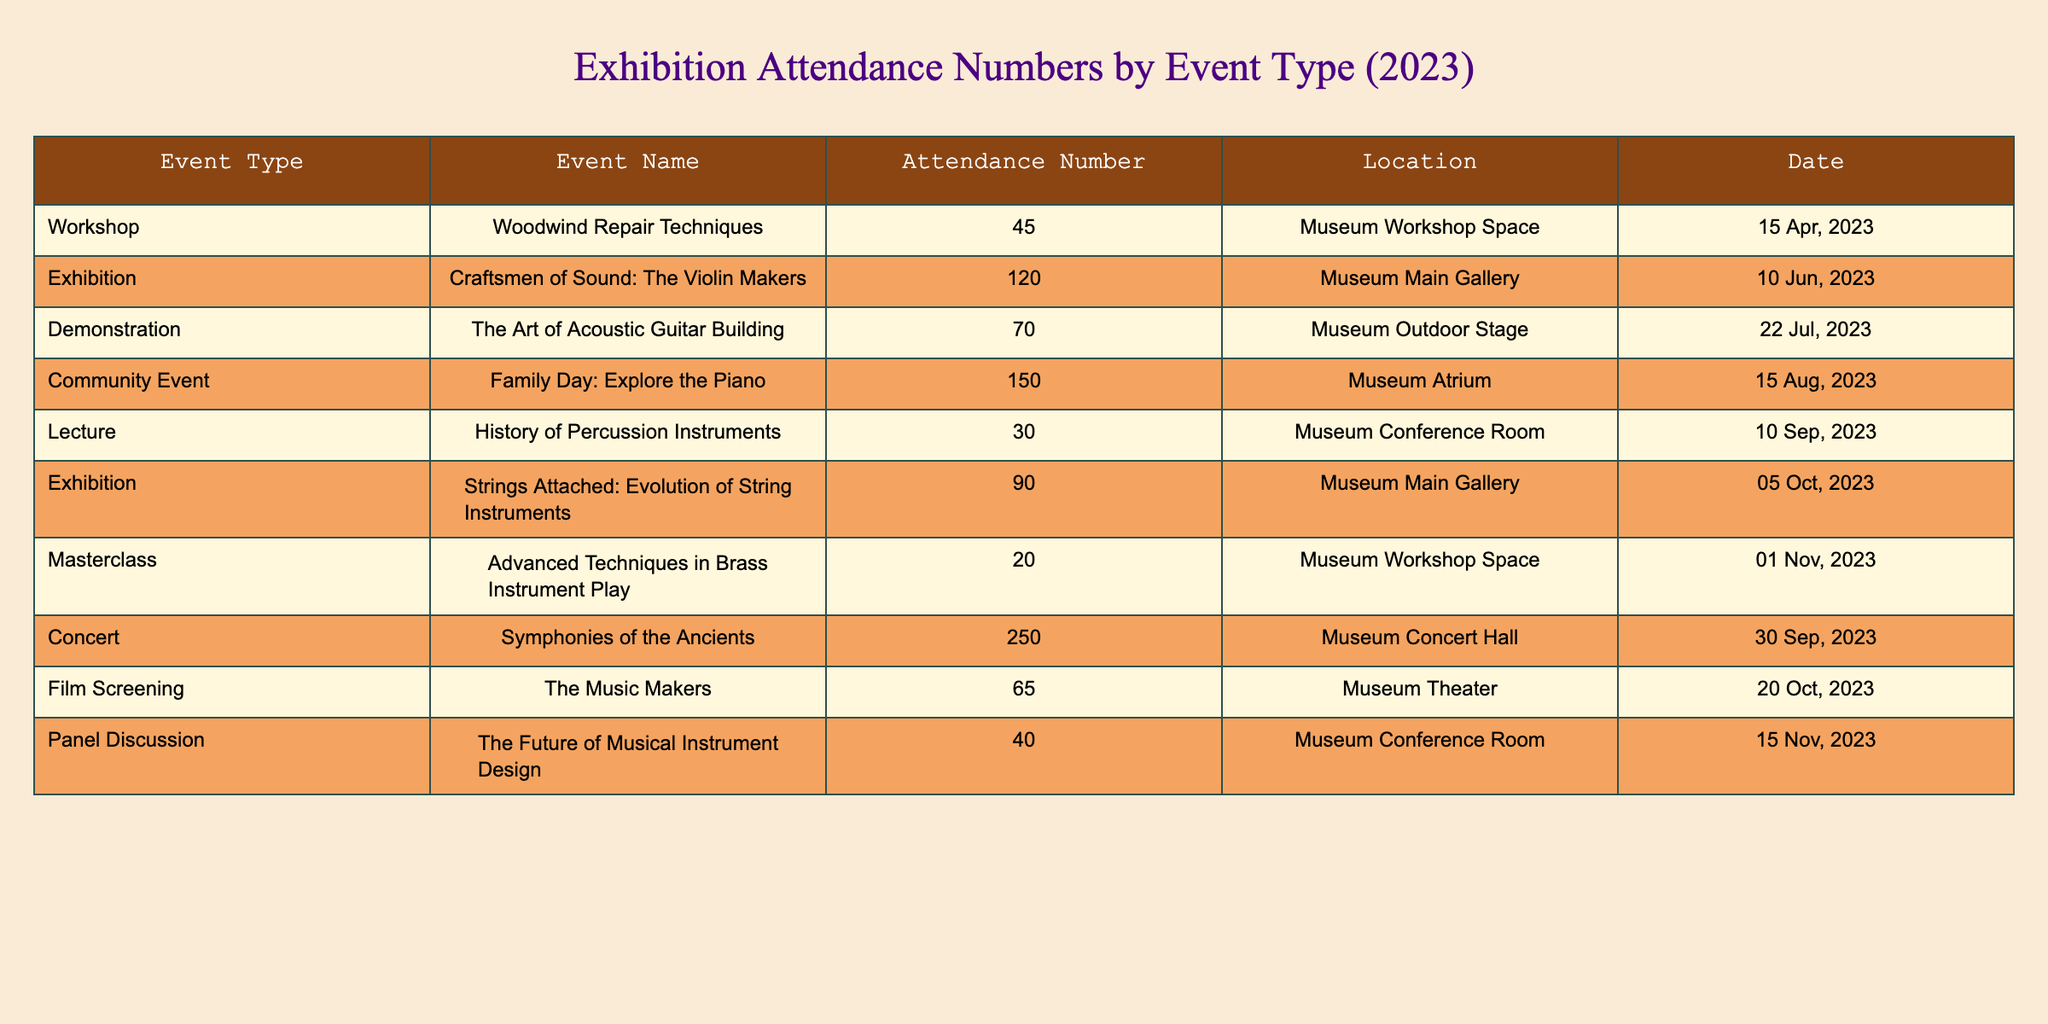What is the event with the highest attendance? The attendance numbers for each event are listed in the table. By comparing the values, the event "Symphonies of the Ancients" has the highest attendance at 250.
Answer: 250 How many exhibitions were held in 2023? The table lists two events with the type "Exhibition": "Craftsmen of Sound: The Violin Makers" and "Strings Attached: Evolution of String Instruments." Therefore, there are 2 exhibitions.
Answer: 2 What is the total attendance for community events? There is one community event listed: "Family Day: Explore the Piano," which had an attendance of 150. There are no other community events to sum.
Answer: 150 Which event took place on November 1, 2023? The event listed for November 1, 2023, is "Advanced Techniques in Brass Instrument Play." This can be found by checking the date column for the mentioned date.
Answer: Advanced Techniques in Brass Instrument Play What is the average attendance across all events? To find the average attendance, we first sum all attendance numbers: 45 + 120 + 70 + 150 + 30 + 90 + 20 + 250 + 65 + 40 = 870. There are 10 events in total, so the average is 870/10 = 87.
Answer: 87 Was there any workshop conducted in the museum? The table includes the event "Woodwind Repair Techniques," which is categorized as a workshop. Since it's listed, the answer is yes.
Answer: Yes How many more attendees did the concert have compared to the lecture? The concert "Symphonies of the Ancients" had an attendance of 250, while the lecture "History of Percussion Instruments" had 30 attendees. The difference is 250 - 30 = 220.
Answer: 220 What locations hosted the events on September 10, 2023, and September 30, 2023? The event on September 10, 2023, was a lecture in the Museum Conference Room, and on September 30, 2023, a concert took place in the Museum Concert Hall.
Answer: Conference Room and Concert Hall How many participants attended demonstrations and panels combined? There is one demonstration event with 70 attendees ("The Art of Acoustic Guitar Building") and one panel discussion with 40 attendees. Summing these gives 70 + 40 = 110.
Answer: 110 Was the attendance for workshops generally higher or lower than for lectures? Workshops had the highest attendance at 45, while the lecture attendance was 30. Comparatively, 45 is greater than 30, indicating workshops had higher attendance overall.
Answer: Higher 